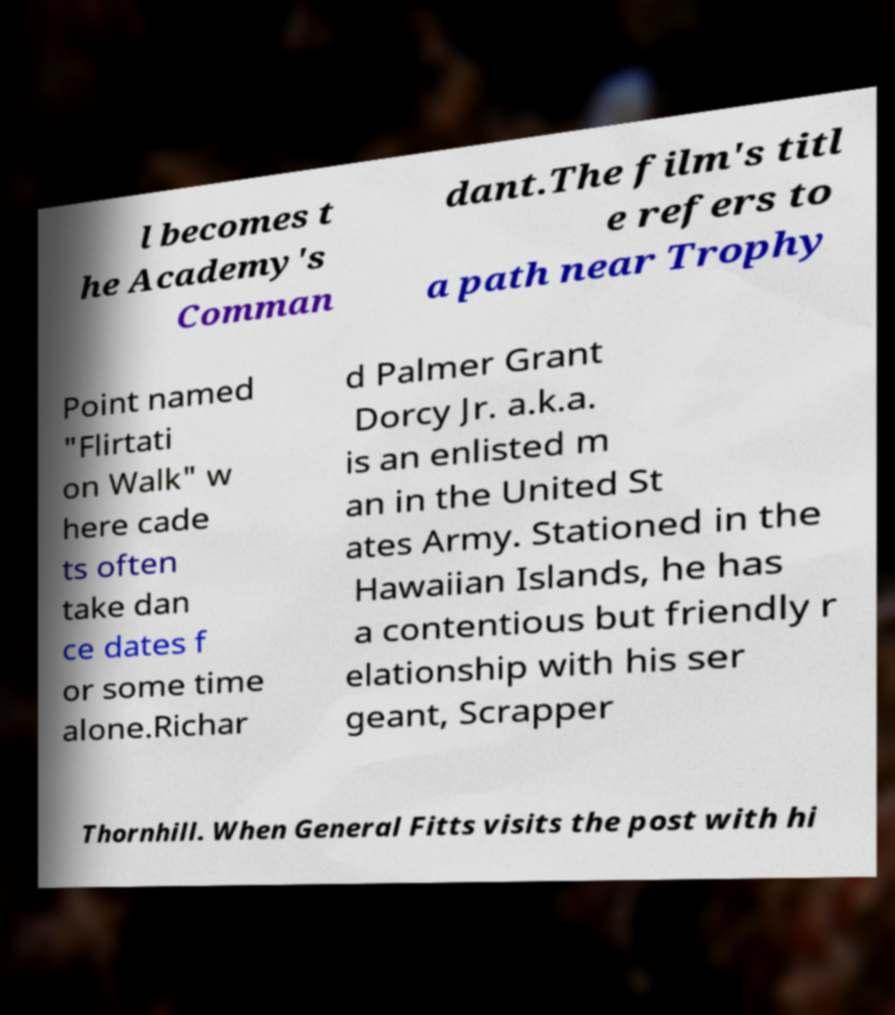Can you accurately transcribe the text from the provided image for me? l becomes t he Academy's Comman dant.The film's titl e refers to a path near Trophy Point named "Flirtati on Walk" w here cade ts often take dan ce dates f or some time alone.Richar d Palmer Grant Dorcy Jr. a.k.a. is an enlisted m an in the United St ates Army. Stationed in the Hawaiian Islands, he has a contentious but friendly r elationship with his ser geant, Scrapper Thornhill. When General Fitts visits the post with hi 